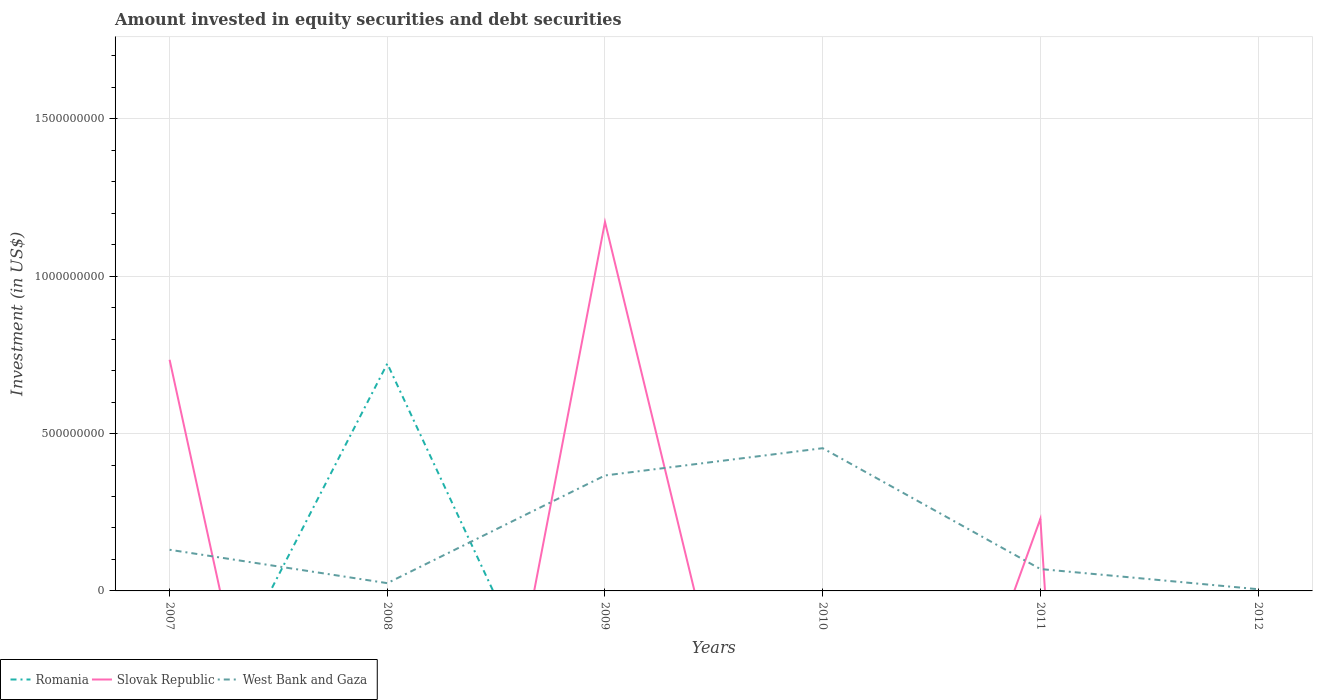How many different coloured lines are there?
Make the answer very short. 3. Does the line corresponding to Romania intersect with the line corresponding to Slovak Republic?
Give a very brief answer. Yes. Is the number of lines equal to the number of legend labels?
Your answer should be compact. No. Across all years, what is the maximum amount invested in equity securities and debt securities in West Bank and Gaza?
Your answer should be compact. 5.43e+06. What is the total amount invested in equity securities and debt securities in West Bank and Gaza in the graph?
Make the answer very short. -8.66e+07. What is the difference between the highest and the second highest amount invested in equity securities and debt securities in West Bank and Gaza?
Make the answer very short. 4.48e+08. What is the difference between the highest and the lowest amount invested in equity securities and debt securities in Slovak Republic?
Give a very brief answer. 2. What is the difference between two consecutive major ticks on the Y-axis?
Ensure brevity in your answer.  5.00e+08. Are the values on the major ticks of Y-axis written in scientific E-notation?
Ensure brevity in your answer.  No. Does the graph contain grids?
Keep it short and to the point. Yes. What is the title of the graph?
Offer a very short reply. Amount invested in equity securities and debt securities. What is the label or title of the Y-axis?
Keep it short and to the point. Investment (in US$). What is the Investment (in US$) of Slovak Republic in 2007?
Provide a succinct answer. 7.34e+08. What is the Investment (in US$) of West Bank and Gaza in 2007?
Your answer should be very brief. 1.31e+08. What is the Investment (in US$) in Romania in 2008?
Provide a short and direct response. 7.22e+08. What is the Investment (in US$) in Slovak Republic in 2008?
Make the answer very short. 0. What is the Investment (in US$) in West Bank and Gaza in 2008?
Offer a very short reply. 2.47e+07. What is the Investment (in US$) of Romania in 2009?
Offer a very short reply. 0. What is the Investment (in US$) in Slovak Republic in 2009?
Offer a terse response. 1.17e+09. What is the Investment (in US$) in West Bank and Gaza in 2009?
Your response must be concise. 3.67e+08. What is the Investment (in US$) in Romania in 2010?
Keep it short and to the point. 0. What is the Investment (in US$) in Slovak Republic in 2010?
Offer a very short reply. 0. What is the Investment (in US$) in West Bank and Gaza in 2010?
Give a very brief answer. 4.53e+08. What is the Investment (in US$) in Romania in 2011?
Your answer should be compact. 0. What is the Investment (in US$) in Slovak Republic in 2011?
Your response must be concise. 2.29e+08. What is the Investment (in US$) of West Bank and Gaza in 2011?
Provide a succinct answer. 6.95e+07. What is the Investment (in US$) in West Bank and Gaza in 2012?
Make the answer very short. 5.43e+06. Across all years, what is the maximum Investment (in US$) in Romania?
Your answer should be very brief. 7.22e+08. Across all years, what is the maximum Investment (in US$) in Slovak Republic?
Your answer should be compact. 1.17e+09. Across all years, what is the maximum Investment (in US$) in West Bank and Gaza?
Your response must be concise. 4.53e+08. Across all years, what is the minimum Investment (in US$) in Slovak Republic?
Provide a succinct answer. 0. Across all years, what is the minimum Investment (in US$) in West Bank and Gaza?
Offer a terse response. 5.43e+06. What is the total Investment (in US$) in Romania in the graph?
Make the answer very short. 7.22e+08. What is the total Investment (in US$) in Slovak Republic in the graph?
Ensure brevity in your answer.  2.14e+09. What is the total Investment (in US$) of West Bank and Gaza in the graph?
Provide a short and direct response. 1.05e+09. What is the difference between the Investment (in US$) of West Bank and Gaza in 2007 and that in 2008?
Provide a succinct answer. 1.06e+08. What is the difference between the Investment (in US$) in Slovak Republic in 2007 and that in 2009?
Provide a short and direct response. -4.38e+08. What is the difference between the Investment (in US$) in West Bank and Gaza in 2007 and that in 2009?
Provide a short and direct response. -2.36e+08. What is the difference between the Investment (in US$) in West Bank and Gaza in 2007 and that in 2010?
Your response must be concise. -3.23e+08. What is the difference between the Investment (in US$) of Slovak Republic in 2007 and that in 2011?
Offer a terse response. 5.05e+08. What is the difference between the Investment (in US$) of West Bank and Gaza in 2007 and that in 2011?
Offer a very short reply. 6.12e+07. What is the difference between the Investment (in US$) of West Bank and Gaza in 2007 and that in 2012?
Your answer should be compact. 1.25e+08. What is the difference between the Investment (in US$) in West Bank and Gaza in 2008 and that in 2009?
Make the answer very short. -3.42e+08. What is the difference between the Investment (in US$) in West Bank and Gaza in 2008 and that in 2010?
Give a very brief answer. -4.29e+08. What is the difference between the Investment (in US$) of West Bank and Gaza in 2008 and that in 2011?
Make the answer very short. -4.48e+07. What is the difference between the Investment (in US$) of West Bank and Gaza in 2008 and that in 2012?
Ensure brevity in your answer.  1.92e+07. What is the difference between the Investment (in US$) in West Bank and Gaza in 2009 and that in 2010?
Provide a short and direct response. -8.66e+07. What is the difference between the Investment (in US$) of Slovak Republic in 2009 and that in 2011?
Provide a succinct answer. 9.43e+08. What is the difference between the Investment (in US$) in West Bank and Gaza in 2009 and that in 2011?
Keep it short and to the point. 2.97e+08. What is the difference between the Investment (in US$) in West Bank and Gaza in 2009 and that in 2012?
Keep it short and to the point. 3.61e+08. What is the difference between the Investment (in US$) in West Bank and Gaza in 2010 and that in 2011?
Offer a terse response. 3.84e+08. What is the difference between the Investment (in US$) of West Bank and Gaza in 2010 and that in 2012?
Make the answer very short. 4.48e+08. What is the difference between the Investment (in US$) in West Bank and Gaza in 2011 and that in 2012?
Provide a succinct answer. 6.41e+07. What is the difference between the Investment (in US$) of Slovak Republic in 2007 and the Investment (in US$) of West Bank and Gaza in 2008?
Your answer should be very brief. 7.10e+08. What is the difference between the Investment (in US$) in Slovak Republic in 2007 and the Investment (in US$) in West Bank and Gaza in 2009?
Offer a very short reply. 3.68e+08. What is the difference between the Investment (in US$) in Slovak Republic in 2007 and the Investment (in US$) in West Bank and Gaza in 2010?
Your response must be concise. 2.81e+08. What is the difference between the Investment (in US$) in Slovak Republic in 2007 and the Investment (in US$) in West Bank and Gaza in 2011?
Your answer should be compact. 6.65e+08. What is the difference between the Investment (in US$) of Slovak Republic in 2007 and the Investment (in US$) of West Bank and Gaza in 2012?
Give a very brief answer. 7.29e+08. What is the difference between the Investment (in US$) of Romania in 2008 and the Investment (in US$) of Slovak Republic in 2009?
Offer a terse response. -4.50e+08. What is the difference between the Investment (in US$) of Romania in 2008 and the Investment (in US$) of West Bank and Gaza in 2009?
Give a very brief answer. 3.55e+08. What is the difference between the Investment (in US$) of Romania in 2008 and the Investment (in US$) of West Bank and Gaza in 2010?
Offer a terse response. 2.69e+08. What is the difference between the Investment (in US$) of Romania in 2008 and the Investment (in US$) of Slovak Republic in 2011?
Provide a short and direct response. 4.93e+08. What is the difference between the Investment (in US$) in Romania in 2008 and the Investment (in US$) in West Bank and Gaza in 2011?
Your answer should be very brief. 6.52e+08. What is the difference between the Investment (in US$) of Romania in 2008 and the Investment (in US$) of West Bank and Gaza in 2012?
Your response must be concise. 7.17e+08. What is the difference between the Investment (in US$) in Slovak Republic in 2009 and the Investment (in US$) in West Bank and Gaza in 2010?
Offer a terse response. 7.19e+08. What is the difference between the Investment (in US$) in Slovak Republic in 2009 and the Investment (in US$) in West Bank and Gaza in 2011?
Offer a very short reply. 1.10e+09. What is the difference between the Investment (in US$) of Slovak Republic in 2009 and the Investment (in US$) of West Bank and Gaza in 2012?
Offer a terse response. 1.17e+09. What is the difference between the Investment (in US$) in Slovak Republic in 2011 and the Investment (in US$) in West Bank and Gaza in 2012?
Offer a very short reply. 2.24e+08. What is the average Investment (in US$) in Romania per year?
Make the answer very short. 1.20e+08. What is the average Investment (in US$) of Slovak Republic per year?
Provide a short and direct response. 3.56e+08. What is the average Investment (in US$) in West Bank and Gaza per year?
Make the answer very short. 1.75e+08. In the year 2007, what is the difference between the Investment (in US$) in Slovak Republic and Investment (in US$) in West Bank and Gaza?
Provide a succinct answer. 6.04e+08. In the year 2008, what is the difference between the Investment (in US$) of Romania and Investment (in US$) of West Bank and Gaza?
Give a very brief answer. 6.97e+08. In the year 2009, what is the difference between the Investment (in US$) of Slovak Republic and Investment (in US$) of West Bank and Gaza?
Offer a terse response. 8.05e+08. In the year 2011, what is the difference between the Investment (in US$) of Slovak Republic and Investment (in US$) of West Bank and Gaza?
Provide a short and direct response. 1.60e+08. What is the ratio of the Investment (in US$) of West Bank and Gaza in 2007 to that in 2008?
Make the answer very short. 5.3. What is the ratio of the Investment (in US$) in Slovak Republic in 2007 to that in 2009?
Provide a succinct answer. 0.63. What is the ratio of the Investment (in US$) in West Bank and Gaza in 2007 to that in 2009?
Provide a succinct answer. 0.36. What is the ratio of the Investment (in US$) in West Bank and Gaza in 2007 to that in 2010?
Your response must be concise. 0.29. What is the ratio of the Investment (in US$) of Slovak Republic in 2007 to that in 2011?
Provide a succinct answer. 3.21. What is the ratio of the Investment (in US$) of West Bank and Gaza in 2007 to that in 2011?
Make the answer very short. 1.88. What is the ratio of the Investment (in US$) of West Bank and Gaza in 2007 to that in 2012?
Provide a short and direct response. 24.06. What is the ratio of the Investment (in US$) in West Bank and Gaza in 2008 to that in 2009?
Offer a very short reply. 0.07. What is the ratio of the Investment (in US$) of West Bank and Gaza in 2008 to that in 2010?
Provide a short and direct response. 0.05. What is the ratio of the Investment (in US$) in West Bank and Gaza in 2008 to that in 2011?
Offer a very short reply. 0.35. What is the ratio of the Investment (in US$) in West Bank and Gaza in 2008 to that in 2012?
Offer a very short reply. 4.54. What is the ratio of the Investment (in US$) of West Bank and Gaza in 2009 to that in 2010?
Make the answer very short. 0.81. What is the ratio of the Investment (in US$) in Slovak Republic in 2009 to that in 2011?
Your answer should be very brief. 5.12. What is the ratio of the Investment (in US$) of West Bank and Gaza in 2009 to that in 2011?
Offer a very short reply. 5.28. What is the ratio of the Investment (in US$) of West Bank and Gaza in 2009 to that in 2012?
Give a very brief answer. 67.51. What is the ratio of the Investment (in US$) in West Bank and Gaza in 2010 to that in 2011?
Your answer should be compact. 6.52. What is the ratio of the Investment (in US$) of West Bank and Gaza in 2010 to that in 2012?
Ensure brevity in your answer.  83.45. What is the ratio of the Investment (in US$) in West Bank and Gaza in 2011 to that in 2012?
Give a very brief answer. 12.79. What is the difference between the highest and the second highest Investment (in US$) in Slovak Republic?
Your answer should be very brief. 4.38e+08. What is the difference between the highest and the second highest Investment (in US$) in West Bank and Gaza?
Provide a short and direct response. 8.66e+07. What is the difference between the highest and the lowest Investment (in US$) in Romania?
Keep it short and to the point. 7.22e+08. What is the difference between the highest and the lowest Investment (in US$) in Slovak Republic?
Provide a succinct answer. 1.17e+09. What is the difference between the highest and the lowest Investment (in US$) of West Bank and Gaza?
Make the answer very short. 4.48e+08. 